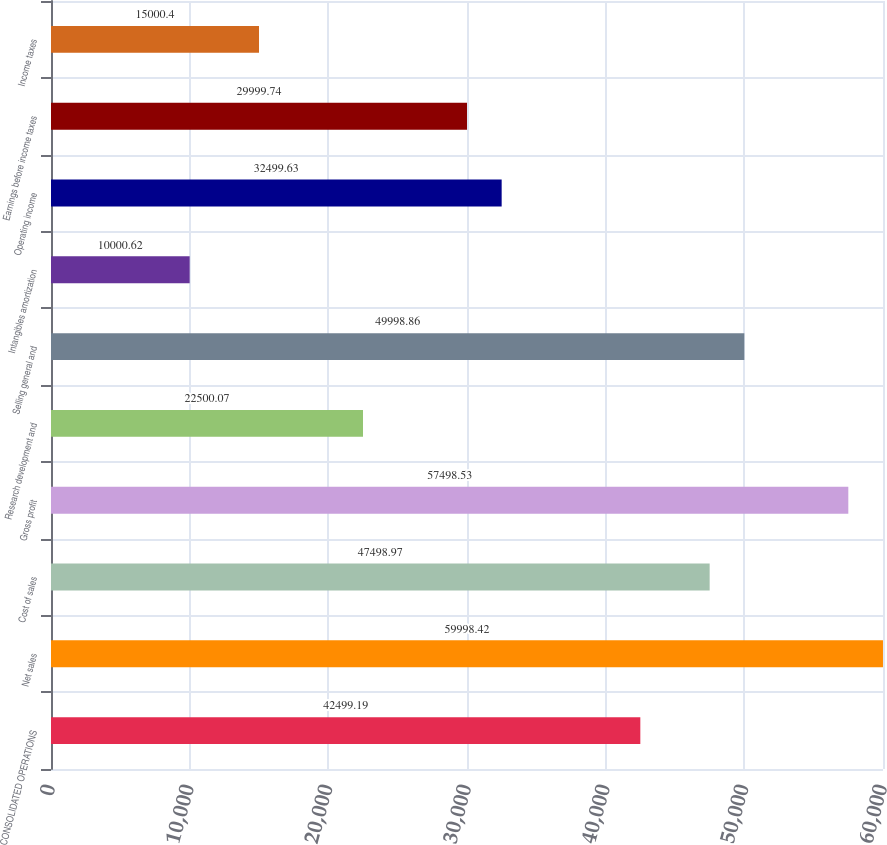Convert chart. <chart><loc_0><loc_0><loc_500><loc_500><bar_chart><fcel>CONSOLIDATED OPERATIONS<fcel>Net sales<fcel>Cost of sales<fcel>Gross profit<fcel>Research development and<fcel>Selling general and<fcel>Intangibles amortization<fcel>Operating income<fcel>Earnings before income taxes<fcel>Income taxes<nl><fcel>42499.2<fcel>59998.4<fcel>47499<fcel>57498.5<fcel>22500.1<fcel>49998.9<fcel>10000.6<fcel>32499.6<fcel>29999.7<fcel>15000.4<nl></chart> 